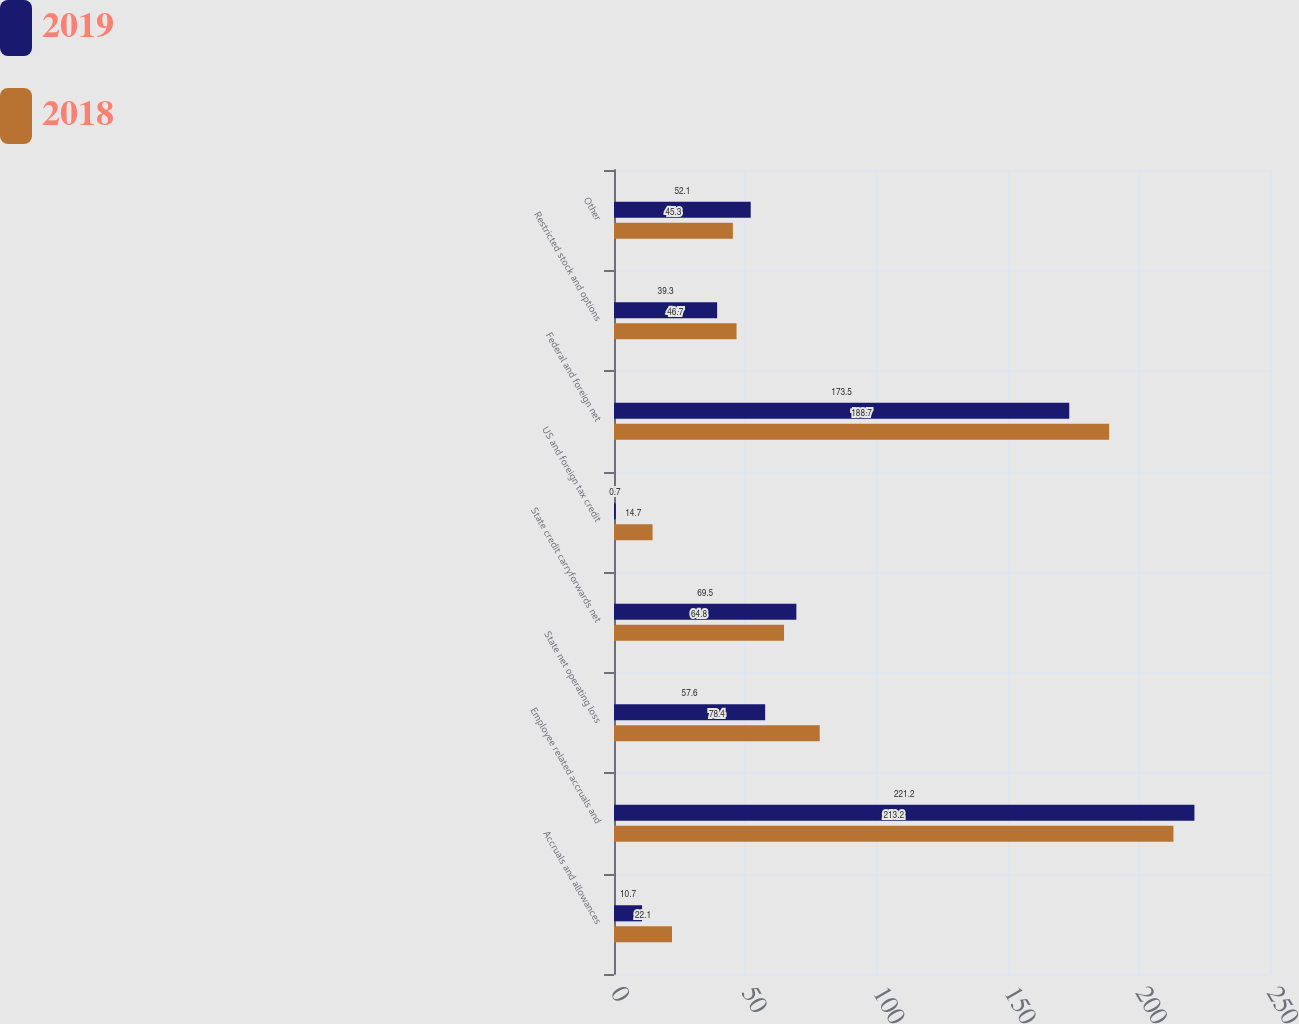Convert chart to OTSL. <chart><loc_0><loc_0><loc_500><loc_500><stacked_bar_chart><ecel><fcel>Accruals and allowances<fcel>Employee related accruals and<fcel>State net operating loss<fcel>State credit carryforwards net<fcel>US and foreign tax credit<fcel>Federal and foreign net<fcel>Restricted stock and options<fcel>Other<nl><fcel>2019<fcel>10.7<fcel>221.2<fcel>57.6<fcel>69.5<fcel>0.7<fcel>173.5<fcel>39.3<fcel>52.1<nl><fcel>2018<fcel>22.1<fcel>213.2<fcel>78.4<fcel>64.8<fcel>14.7<fcel>188.7<fcel>46.7<fcel>45.3<nl></chart> 